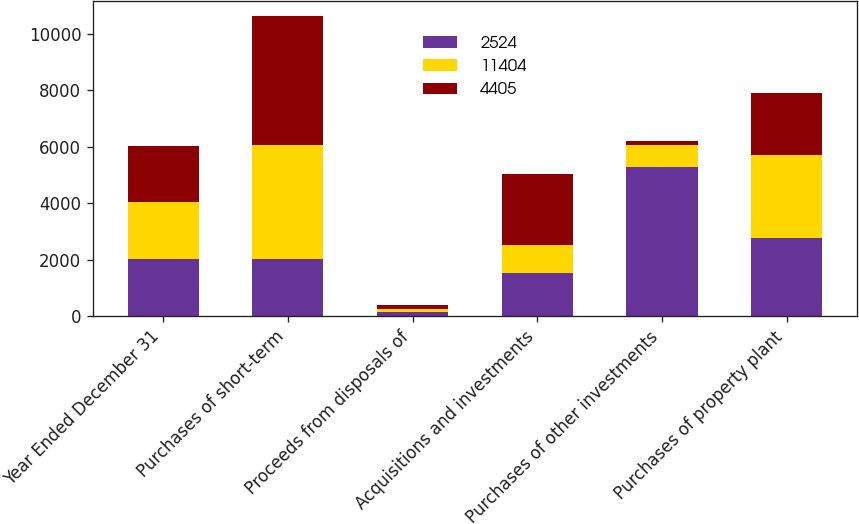<chart> <loc_0><loc_0><loc_500><loc_500><stacked_bar_chart><ecel><fcel>Year Ended December 31<fcel>Purchases of short-term<fcel>Proceeds from disposals of<fcel>Acquisitions and investments<fcel>Purchases of other investments<fcel>Purchases of property plant<nl><fcel>2524<fcel>2012<fcel>2012<fcel>143<fcel>1535<fcel>5266<fcel>2780<nl><fcel>11404<fcel>2011<fcel>4057<fcel>101<fcel>977<fcel>787<fcel>2920<nl><fcel>4405<fcel>2010<fcel>4579<fcel>134<fcel>2511<fcel>132<fcel>2215<nl></chart> 